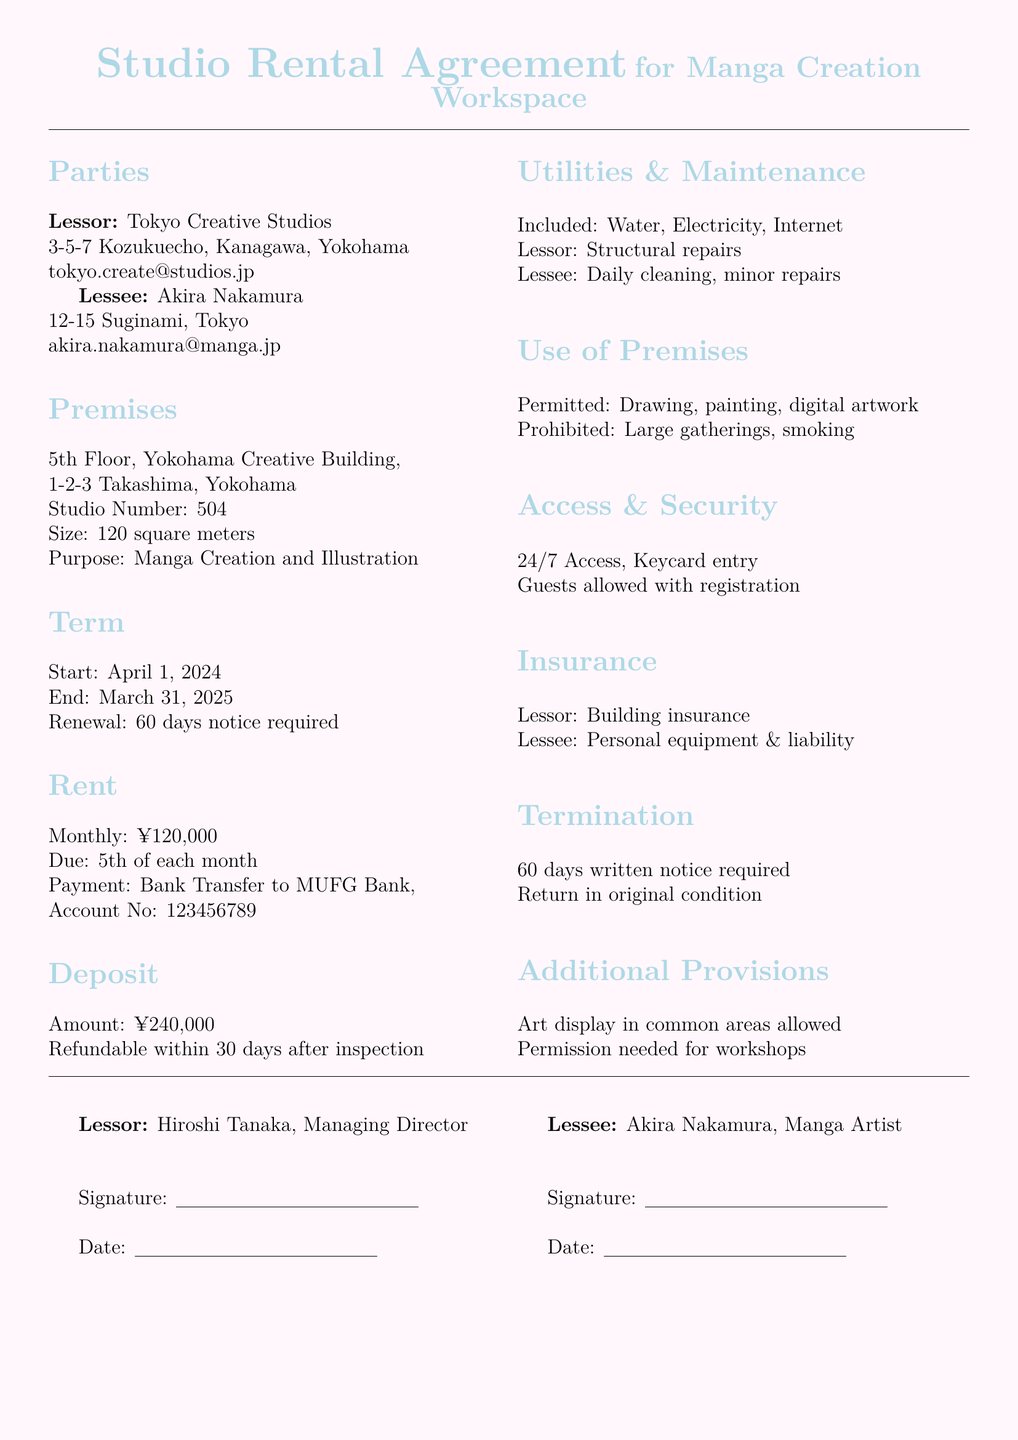what is the monthly rent? The monthly rent is explicitly stated in the agreement as ¥120,000.
Answer: ¥120,000 who is the lessee? The lessee's name, as listed in the agreement, is Akira Nakamura.
Answer: Akira Nakamura what is the size of the studio? The size of the studio is mentioned as 120 square meters in the document.
Answer: 120 square meters when does the rental agreement start? The start date of the rental agreement is specified as April 1, 2024.
Answer: April 1, 2024 what is the amount of the deposit? The agreement indicates that the deposit amount is ¥240,000.
Answer: ¥240,000 how long is the lease term? The lease term is from April 1, 2024 to March 31, 2025, totaling one year.
Answer: one year what utilities are included? The document states that water, electricity, and internet are included.
Answer: Water, Electricity, Internet what is prohibited in the use of premises? The agreement states that large gatherings and smoking are prohibited.
Answer: Large gatherings, smoking what notice is required for termination? The termination clause requires 60 days written notice to be given.
Answer: 60 days written notice 